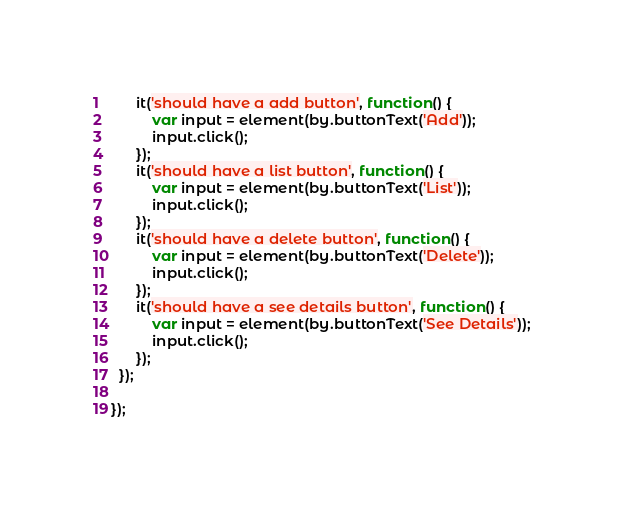<code> <loc_0><loc_0><loc_500><loc_500><_JavaScript_>      it('should have a add button', function() {
          var input = element(by.buttonText('Add'));
          input.click();
      });
      it('should have a list button', function() {
          var input = element(by.buttonText('List'));
          input.click();
      });
      it('should have a delete button', function() {
          var input = element(by.buttonText('Delete'));
          input.click();
      });
      it('should have a see details button', function() {
          var input = element(by.buttonText('See Details'));
          input.click();
      });
  });

});
</code> 